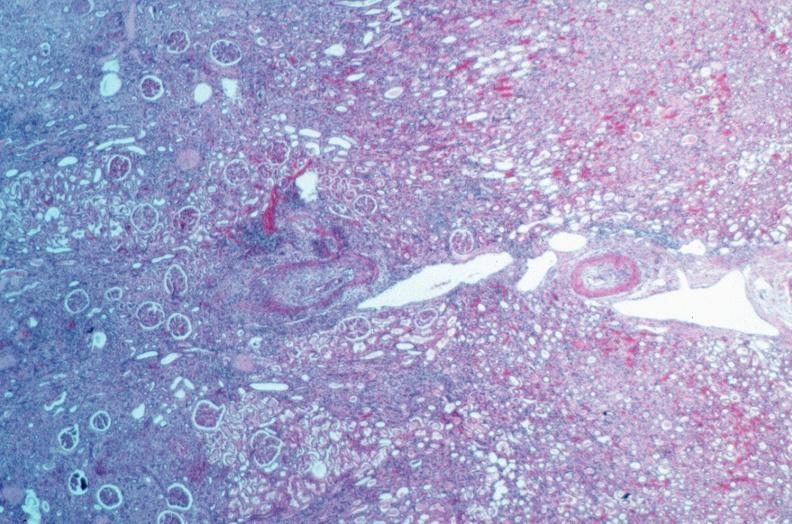s retroperitoneal leiomyosarcoma present?
Answer the question using a single word or phrase. No 